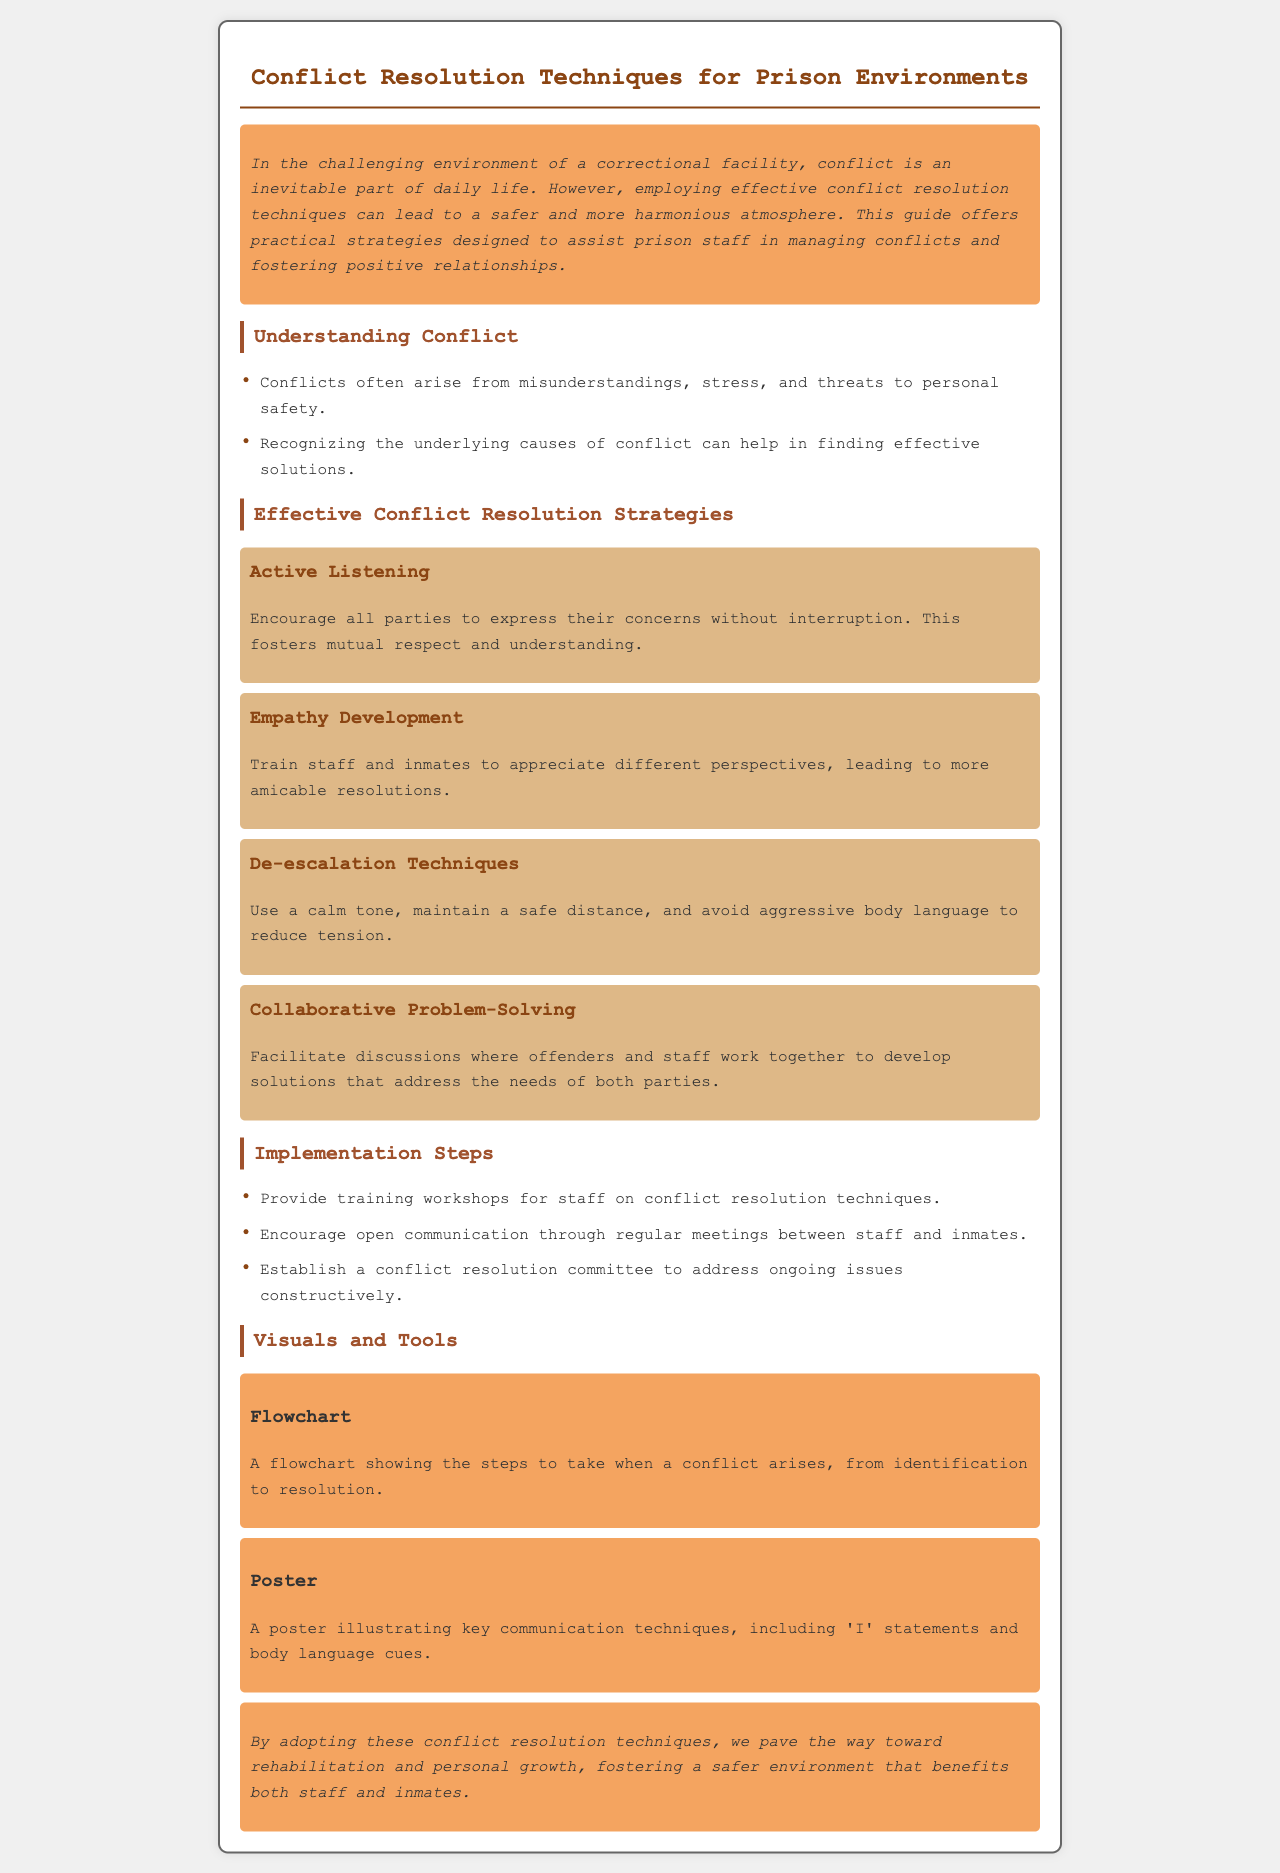What is the title of the brochure? The title is specified at the top of the brochure, indicating the focus of the document.
Answer: Conflict Resolution Techniques for Prison Environments What is one underlying cause of conflict mentioned? The document lists specific factors that can lead to conflicts, found in the understanding section.
Answer: Misunderstandings What technique encourages parties to express their concerns without interruption? This technique is specifically highlighted in the strategies section as promoting mutual respect.
Answer: Active Listening What should be established to address ongoing issues constructively? The document suggests a specific group or committee for addressing conflicts, indicating its importance.
Answer: Conflict resolution committee What is a visual tool mentioned in the brochure? The brochure includes reference to visual aids that support understanding of key concepts.
Answer: Flowchart What tone should be used to reduce tension during conflicts? The document specifies a certain demeanor to foster a calmer environment.
Answer: Calm tone How many conflict resolution strategies are listed? By counting the strategies outlined in the document, we can provide a precise total.
Answer: Four 